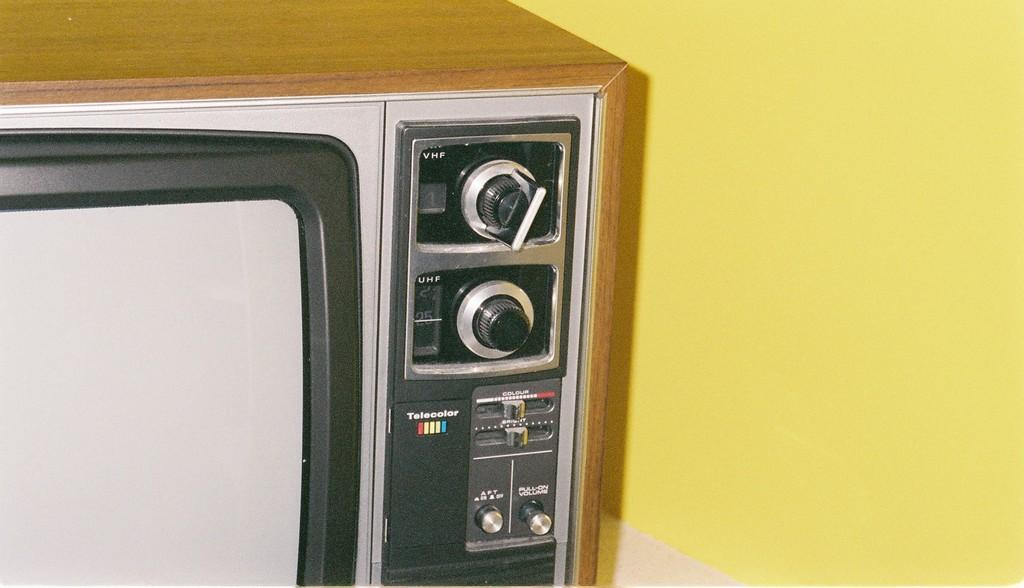<image>
Write a terse but informative summary of the picture. A picture of an old style TV that has the word technicolor written on it. 